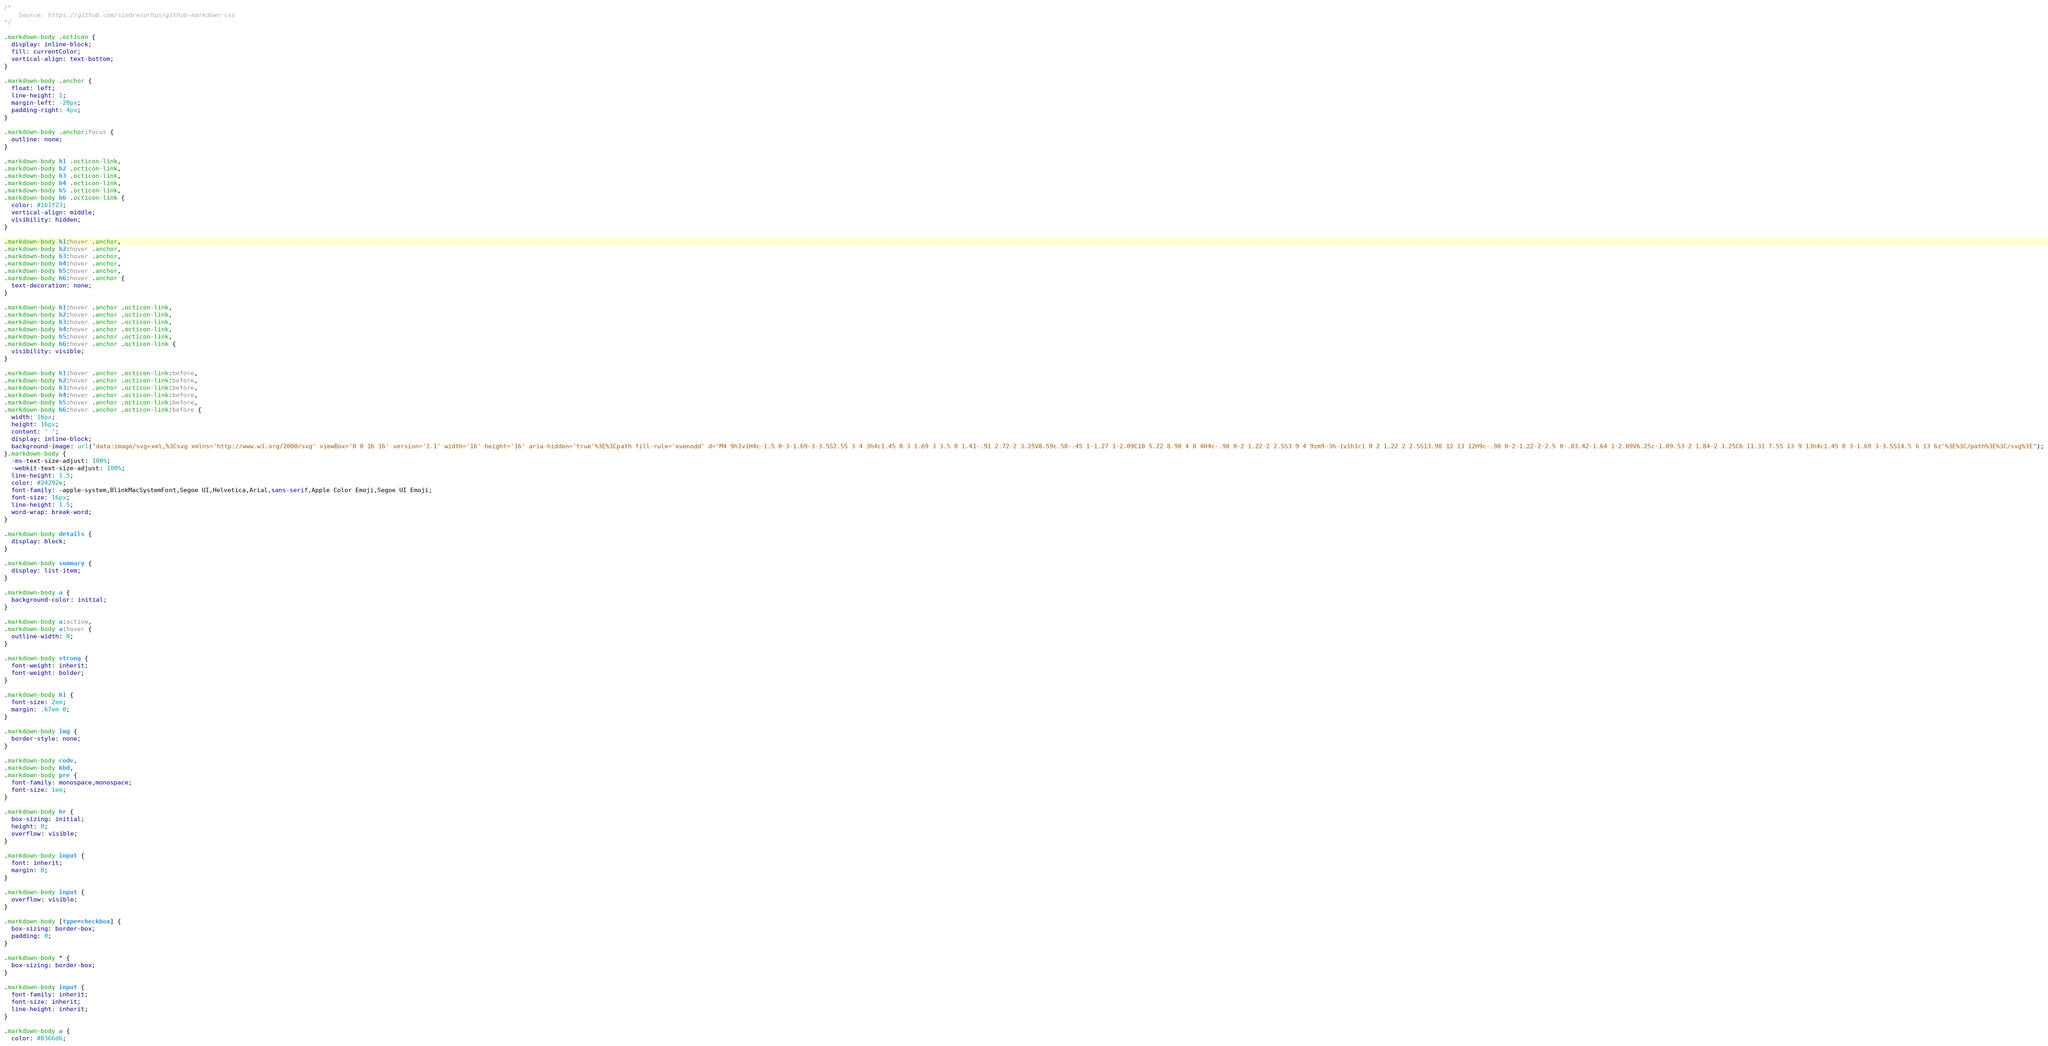<code> <loc_0><loc_0><loc_500><loc_500><_CSS_>/*
    Source: https://github.com/sindresorhus/github-markdown-css
*/

.markdown-body .octicon {
  display: inline-block;
  fill: currentColor;
  vertical-align: text-bottom;
}

.markdown-body .anchor {
  float: left;
  line-height: 1;
  margin-left: -20px;
  padding-right: 4px;
}

.markdown-body .anchor:focus {
  outline: none;
}

.markdown-body h1 .octicon-link,
.markdown-body h2 .octicon-link,
.markdown-body h3 .octicon-link,
.markdown-body h4 .octicon-link,
.markdown-body h5 .octicon-link,
.markdown-body h6 .octicon-link {
  color: #1b1f23;
  vertical-align: middle;
  visibility: hidden;
}

.markdown-body h1:hover .anchor,
.markdown-body h2:hover .anchor,
.markdown-body h3:hover .anchor,
.markdown-body h4:hover .anchor,
.markdown-body h5:hover .anchor,
.markdown-body h6:hover .anchor {
  text-decoration: none;
}

.markdown-body h1:hover .anchor .octicon-link,
.markdown-body h2:hover .anchor .octicon-link,
.markdown-body h3:hover .anchor .octicon-link,
.markdown-body h4:hover .anchor .octicon-link,
.markdown-body h5:hover .anchor .octicon-link,
.markdown-body h6:hover .anchor .octicon-link {
  visibility: visible;
}

.markdown-body h1:hover .anchor .octicon-link:before,
.markdown-body h2:hover .anchor .octicon-link:before,
.markdown-body h3:hover .anchor .octicon-link:before,
.markdown-body h4:hover .anchor .octicon-link:before,
.markdown-body h5:hover .anchor .octicon-link:before,
.markdown-body h6:hover .anchor .octicon-link:before {
  width: 16px;
  height: 16px;
  content: ' ';
  display: inline-block;
  background-image: url("data:image/svg+xml,%3Csvg xmlns='http://www.w3.org/2000/svg' viewBox='0 0 16 16' version='1.1' width='16' height='16' aria-hidden='true'%3E%3Cpath fill-rule='evenodd' d='M4 9h1v1H4c-1.5 0-3-1.69-3-3.5S2.55 3 4 3h4c1.45 0 3 1.69 3 3.5 0 1.41-.91 2.72-2 3.25V8.59c.58-.45 1-1.27 1-2.09C10 5.22 8.98 4 8 4H4c-.98 0-2 1.22-2 2.5S3 9 4 9zm9-3h-1v1h1c1 0 2 1.22 2 2.5S13.98 12 13 12H9c-.98 0-2-1.22-2-2.5 0-.83.42-1.64 1-2.09V6.25c-1.09.53-2 1.84-2 3.25C6 11.31 7.55 13 9 13h4c1.45 0 3-1.69 3-3.5S14.5 6 13 6z'%3E%3C/path%3E%3C/svg%3E");
}.markdown-body {
  -ms-text-size-adjust: 100%;
  -webkit-text-size-adjust: 100%;
  line-height: 1.5;
  color: #24292e;
  font-family: -apple-system,BlinkMacSystemFont,Segoe UI,Helvetica,Arial,sans-serif,Apple Color Emoji,Segoe UI Emoji;
  font-size: 16px;
  line-height: 1.5;
  word-wrap: break-word;
}

.markdown-body details {
  display: block;
}

.markdown-body summary {
  display: list-item;
}

.markdown-body a {
  background-color: initial;
}

.markdown-body a:active,
.markdown-body a:hover {
  outline-width: 0;
}

.markdown-body strong {
  font-weight: inherit;
  font-weight: bolder;
}

.markdown-body h1 {
  font-size: 2em;
  margin: .67em 0;
}

.markdown-body img {
  border-style: none;
}

.markdown-body code,
.markdown-body kbd,
.markdown-body pre {
  font-family: monospace,monospace;
  font-size: 1em;
}

.markdown-body hr {
  box-sizing: initial;
  height: 0;
  overflow: visible;
}

.markdown-body input {
  font: inherit;
  margin: 0;
}

.markdown-body input {
  overflow: visible;
}

.markdown-body [type=checkbox] {
  box-sizing: border-box;
  padding: 0;
}

.markdown-body * {
  box-sizing: border-box;
}

.markdown-body input {
  font-family: inherit;
  font-size: inherit;
  line-height: inherit;
}

.markdown-body a {
  color: #0366d6;</code> 